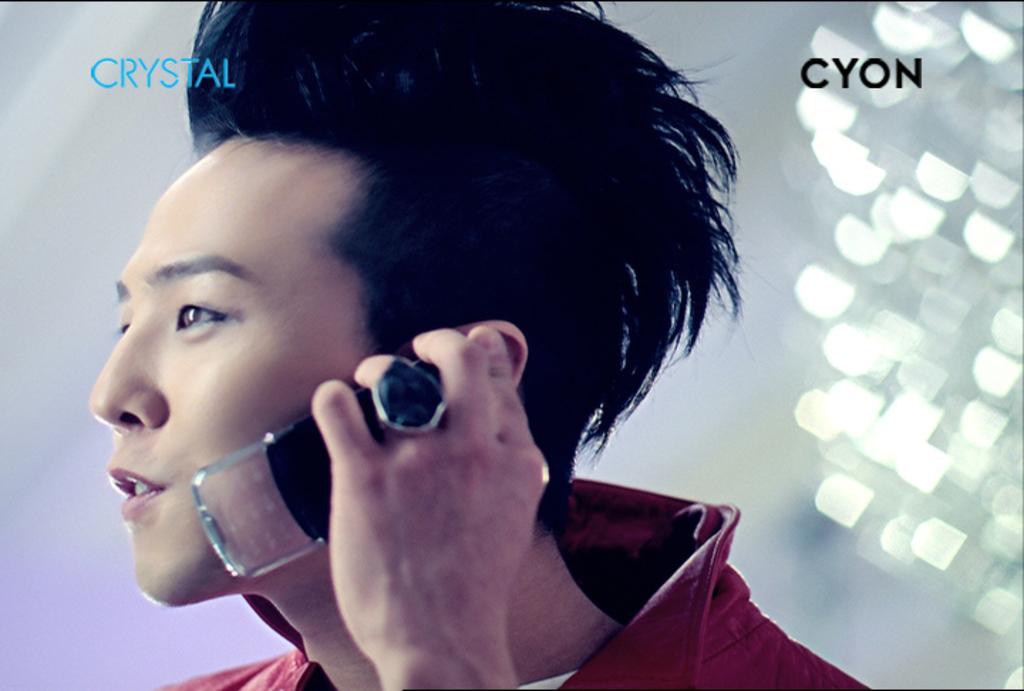What brand is this?
Give a very brief answer. Cyon. What does it say in the top left in blue?
Offer a very short reply. Crystal. 